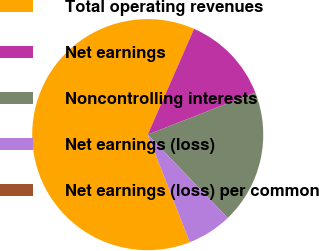<chart> <loc_0><loc_0><loc_500><loc_500><pie_chart><fcel>Total operating revenues<fcel>Net earnings<fcel>Noncontrolling interests<fcel>Net earnings (loss)<fcel>Net earnings (loss) per common<nl><fcel>62.5%<fcel>12.5%<fcel>18.75%<fcel>6.25%<fcel>0.0%<nl></chart> 